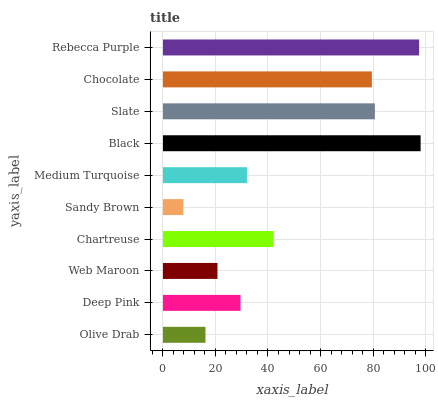Is Sandy Brown the minimum?
Answer yes or no. Yes. Is Black the maximum?
Answer yes or no. Yes. Is Deep Pink the minimum?
Answer yes or no. No. Is Deep Pink the maximum?
Answer yes or no. No. Is Deep Pink greater than Olive Drab?
Answer yes or no. Yes. Is Olive Drab less than Deep Pink?
Answer yes or no. Yes. Is Olive Drab greater than Deep Pink?
Answer yes or no. No. Is Deep Pink less than Olive Drab?
Answer yes or no. No. Is Chartreuse the high median?
Answer yes or no. Yes. Is Medium Turquoise the low median?
Answer yes or no. Yes. Is Web Maroon the high median?
Answer yes or no. No. Is Slate the low median?
Answer yes or no. No. 